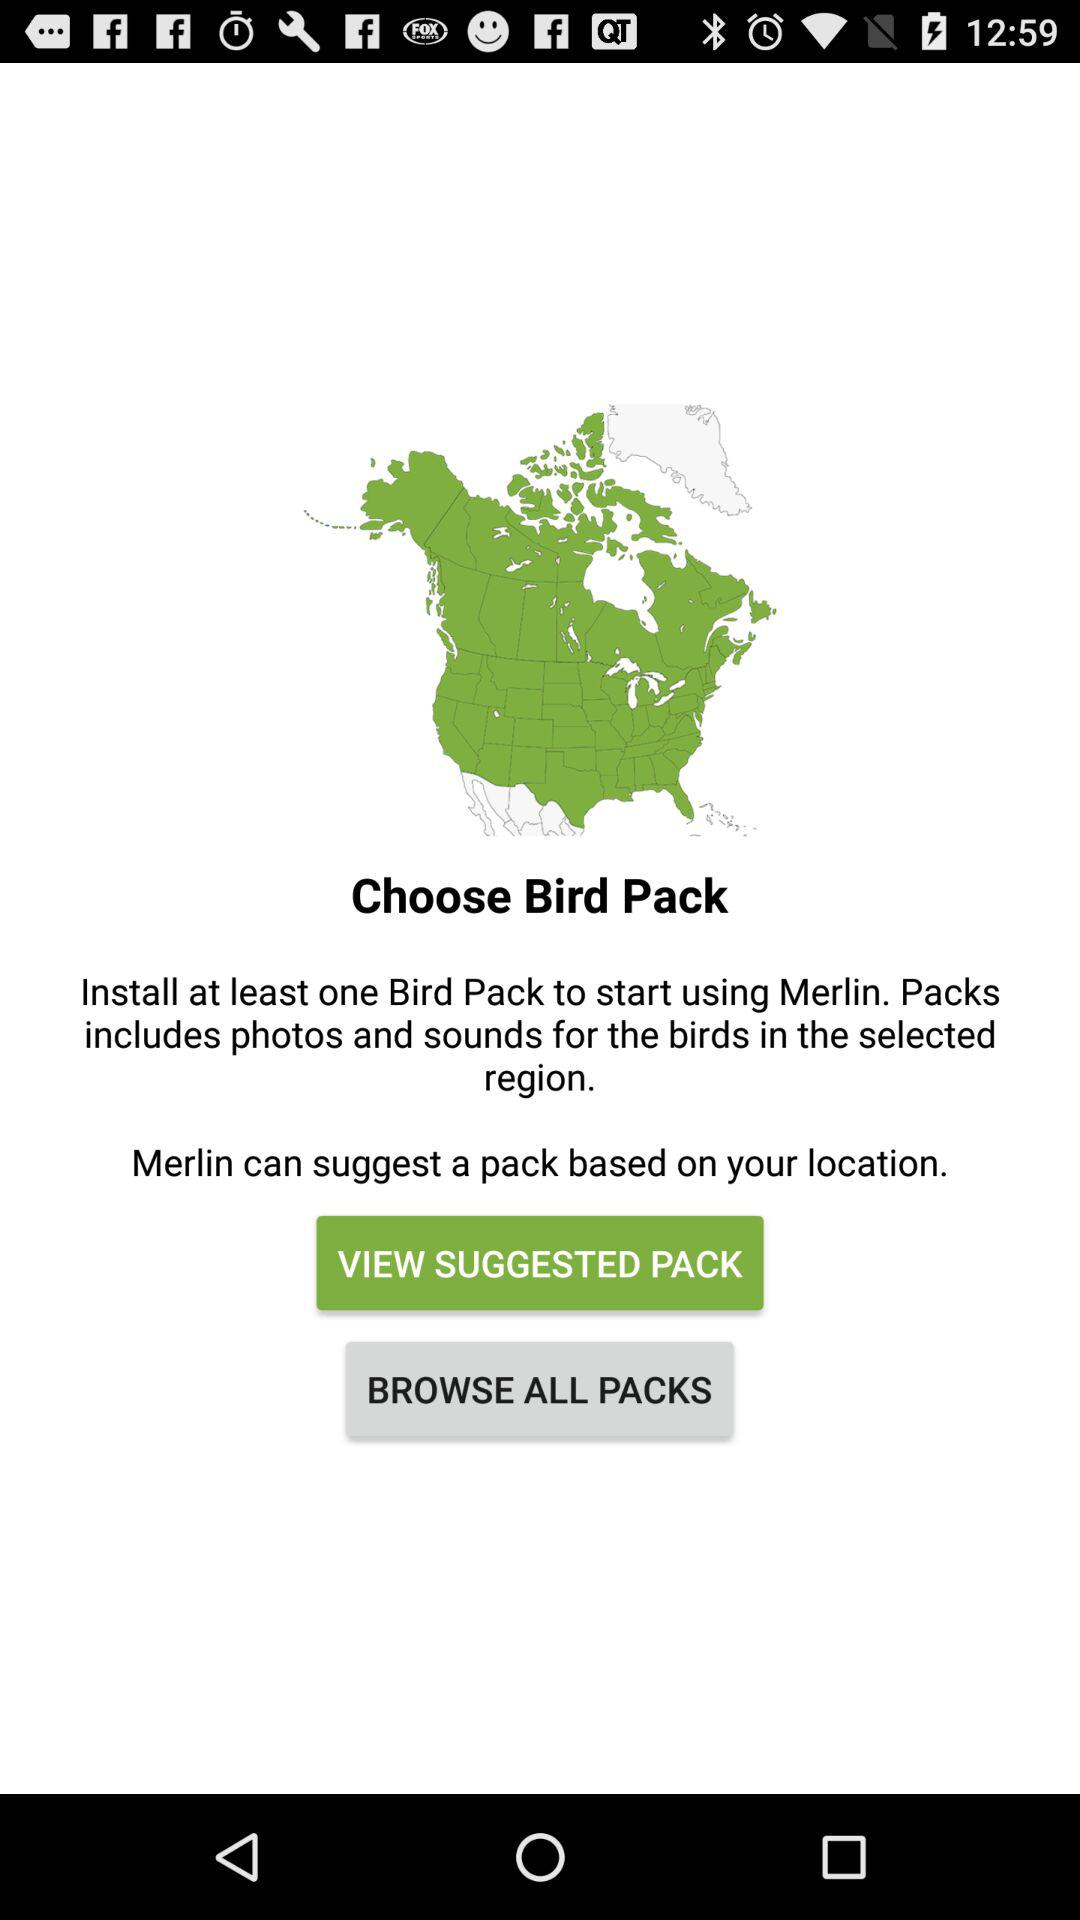What does the pack include? The pack includes photos and sounds for the birds in the selected region. 